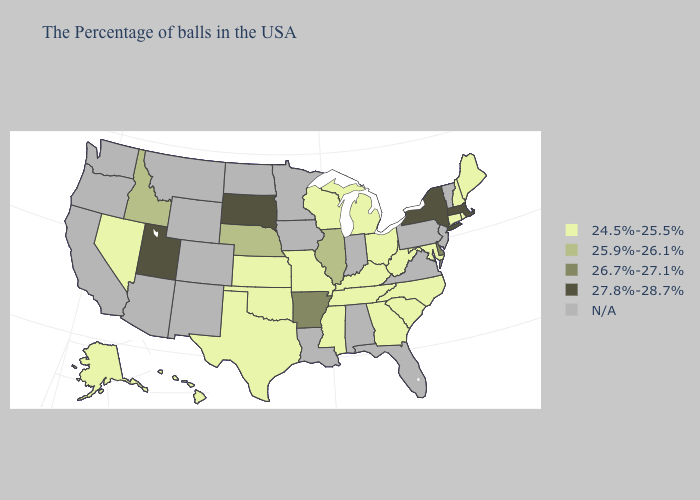What is the lowest value in states that border Colorado?
Quick response, please. 24.5%-25.5%. How many symbols are there in the legend?
Short answer required. 5. Does Nebraska have the lowest value in the MidWest?
Short answer required. No. Does Massachusetts have the highest value in the USA?
Concise answer only. Yes. What is the value of South Carolina?
Give a very brief answer. 24.5%-25.5%. Name the states that have a value in the range N/A?
Keep it brief. Vermont, New Jersey, Pennsylvania, Virginia, Florida, Indiana, Alabama, Louisiana, Minnesota, Iowa, North Dakota, Wyoming, Colorado, New Mexico, Montana, Arizona, California, Washington, Oregon. Does Delaware have the lowest value in the South?
Keep it brief. No. What is the highest value in states that border Delaware?
Keep it brief. 24.5%-25.5%. Among the states that border New Hampshire , does Massachusetts have the highest value?
Write a very short answer. Yes. What is the highest value in the USA?
Keep it brief. 27.8%-28.7%. What is the value of Hawaii?
Be succinct. 24.5%-25.5%. Among the states that border West Virginia , which have the highest value?
Short answer required. Maryland, Ohio, Kentucky. Name the states that have a value in the range 24.5%-25.5%?
Quick response, please. Maine, Rhode Island, New Hampshire, Connecticut, Maryland, North Carolina, South Carolina, West Virginia, Ohio, Georgia, Michigan, Kentucky, Tennessee, Wisconsin, Mississippi, Missouri, Kansas, Oklahoma, Texas, Nevada, Alaska, Hawaii. Among the states that border Illinois , which have the highest value?
Answer briefly. Kentucky, Wisconsin, Missouri. 